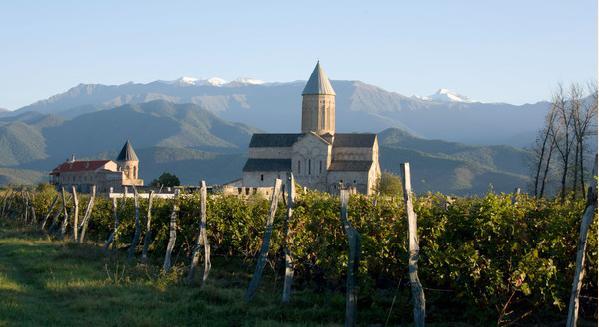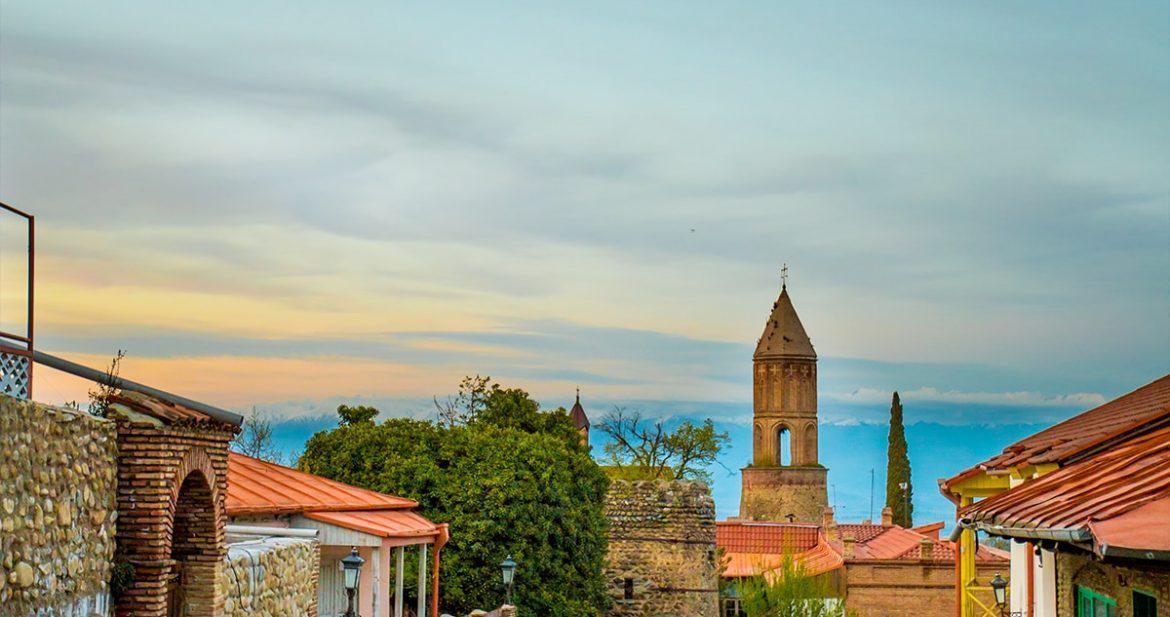The first image is the image on the left, the second image is the image on the right. Assess this claim about the two images: "There is a stone wall in front of the building in one image, but no stone wall in front of the other.". Correct or not? Answer yes or no. No. 